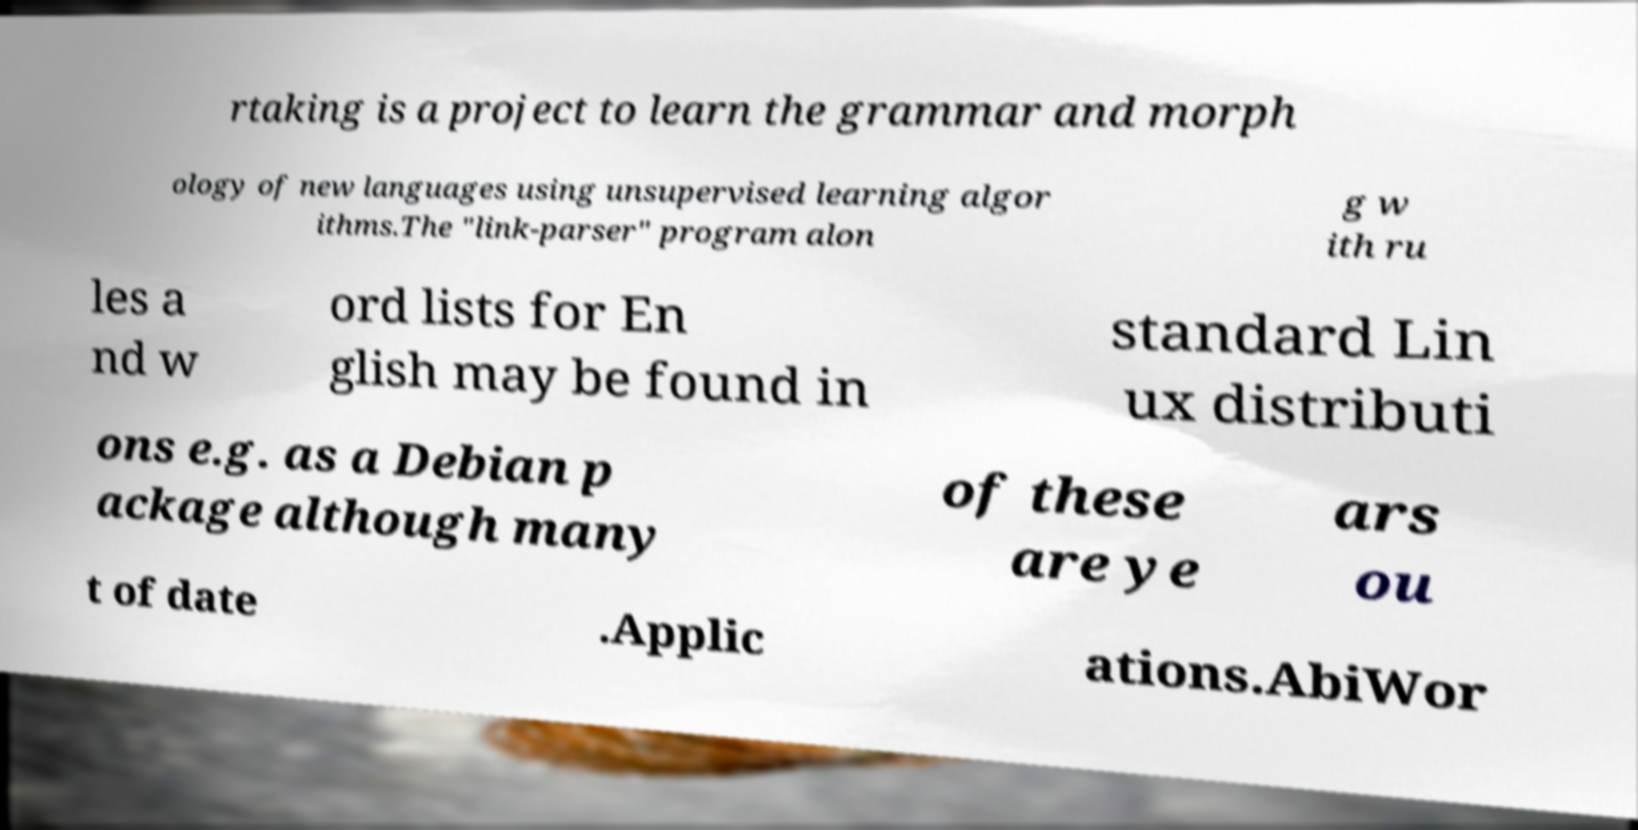Please identify and transcribe the text found in this image. rtaking is a project to learn the grammar and morph ology of new languages using unsupervised learning algor ithms.The "link-parser" program alon g w ith ru les a nd w ord lists for En glish may be found in standard Lin ux distributi ons e.g. as a Debian p ackage although many of these are ye ars ou t of date .Applic ations.AbiWor 